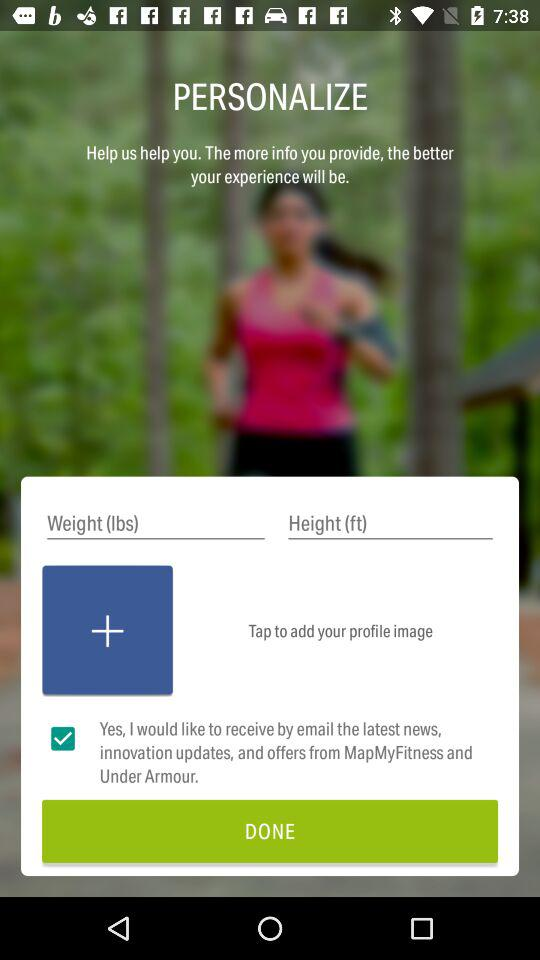What is the status of "Yes, I would like to receive by email"? The status is "on". 